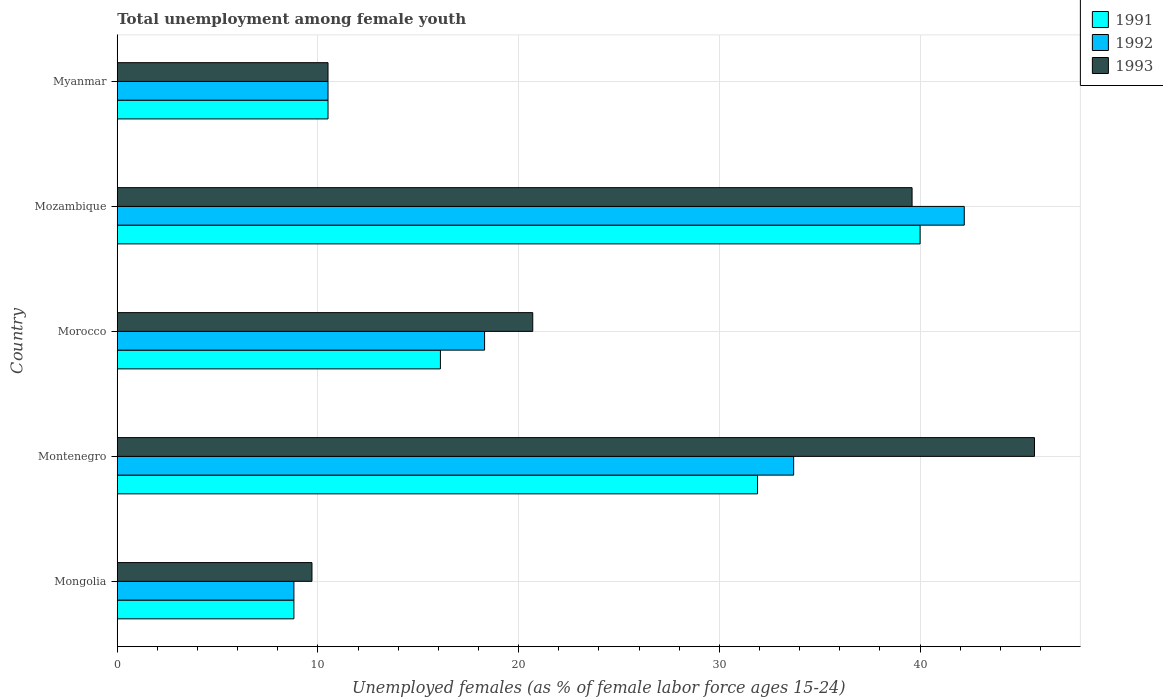Are the number of bars on each tick of the Y-axis equal?
Offer a very short reply. Yes. How many bars are there on the 5th tick from the top?
Provide a succinct answer. 3. How many bars are there on the 4th tick from the bottom?
Your response must be concise. 3. What is the label of the 2nd group of bars from the top?
Provide a succinct answer. Mozambique. What is the percentage of unemployed females in in 1993 in Morocco?
Provide a succinct answer. 20.7. Across all countries, what is the maximum percentage of unemployed females in in 1991?
Your answer should be very brief. 40. Across all countries, what is the minimum percentage of unemployed females in in 1993?
Your answer should be very brief. 9.7. In which country was the percentage of unemployed females in in 1991 maximum?
Give a very brief answer. Mozambique. In which country was the percentage of unemployed females in in 1993 minimum?
Provide a succinct answer. Mongolia. What is the total percentage of unemployed females in in 1992 in the graph?
Give a very brief answer. 113.5. What is the difference between the percentage of unemployed females in in 1993 in Morocco and that in Mozambique?
Make the answer very short. -18.9. What is the difference between the percentage of unemployed females in in 1992 in Mongolia and the percentage of unemployed females in in 1991 in Mozambique?
Keep it short and to the point. -31.2. What is the average percentage of unemployed females in in 1993 per country?
Make the answer very short. 25.24. What is the ratio of the percentage of unemployed females in in 1991 in Mozambique to that in Myanmar?
Keep it short and to the point. 3.81. Is the percentage of unemployed females in in 1993 in Mozambique less than that in Myanmar?
Make the answer very short. No. Is the difference between the percentage of unemployed females in in 1993 in Mongolia and Montenegro greater than the difference between the percentage of unemployed females in in 1992 in Mongolia and Montenegro?
Your answer should be very brief. No. What is the difference between the highest and the second highest percentage of unemployed females in in 1992?
Your answer should be very brief. 8.5. What is the difference between the highest and the lowest percentage of unemployed females in in 1991?
Offer a terse response. 31.2. What does the 3rd bar from the bottom in Mongolia represents?
Your answer should be very brief. 1993. Are all the bars in the graph horizontal?
Your answer should be very brief. Yes. How many countries are there in the graph?
Give a very brief answer. 5. What is the difference between two consecutive major ticks on the X-axis?
Your answer should be very brief. 10. Are the values on the major ticks of X-axis written in scientific E-notation?
Provide a succinct answer. No. Where does the legend appear in the graph?
Your answer should be very brief. Top right. How many legend labels are there?
Keep it short and to the point. 3. How are the legend labels stacked?
Offer a terse response. Vertical. What is the title of the graph?
Your answer should be compact. Total unemployment among female youth. What is the label or title of the X-axis?
Ensure brevity in your answer.  Unemployed females (as % of female labor force ages 15-24). What is the label or title of the Y-axis?
Offer a very short reply. Country. What is the Unemployed females (as % of female labor force ages 15-24) of 1991 in Mongolia?
Your answer should be very brief. 8.8. What is the Unemployed females (as % of female labor force ages 15-24) in 1992 in Mongolia?
Your answer should be compact. 8.8. What is the Unemployed females (as % of female labor force ages 15-24) in 1993 in Mongolia?
Offer a terse response. 9.7. What is the Unemployed females (as % of female labor force ages 15-24) of 1991 in Montenegro?
Your response must be concise. 31.9. What is the Unemployed females (as % of female labor force ages 15-24) of 1992 in Montenegro?
Your answer should be compact. 33.7. What is the Unemployed females (as % of female labor force ages 15-24) of 1993 in Montenegro?
Keep it short and to the point. 45.7. What is the Unemployed females (as % of female labor force ages 15-24) in 1991 in Morocco?
Ensure brevity in your answer.  16.1. What is the Unemployed females (as % of female labor force ages 15-24) of 1992 in Morocco?
Ensure brevity in your answer.  18.3. What is the Unemployed females (as % of female labor force ages 15-24) in 1993 in Morocco?
Your response must be concise. 20.7. What is the Unemployed females (as % of female labor force ages 15-24) of 1992 in Mozambique?
Provide a short and direct response. 42.2. What is the Unemployed females (as % of female labor force ages 15-24) in 1993 in Mozambique?
Your response must be concise. 39.6. What is the Unemployed females (as % of female labor force ages 15-24) in 1993 in Myanmar?
Your answer should be compact. 10.5. Across all countries, what is the maximum Unemployed females (as % of female labor force ages 15-24) in 1992?
Give a very brief answer. 42.2. Across all countries, what is the maximum Unemployed females (as % of female labor force ages 15-24) of 1993?
Your response must be concise. 45.7. Across all countries, what is the minimum Unemployed females (as % of female labor force ages 15-24) of 1991?
Keep it short and to the point. 8.8. Across all countries, what is the minimum Unemployed females (as % of female labor force ages 15-24) of 1992?
Offer a very short reply. 8.8. Across all countries, what is the minimum Unemployed females (as % of female labor force ages 15-24) of 1993?
Your answer should be compact. 9.7. What is the total Unemployed females (as % of female labor force ages 15-24) of 1991 in the graph?
Your answer should be compact. 107.3. What is the total Unemployed females (as % of female labor force ages 15-24) of 1992 in the graph?
Keep it short and to the point. 113.5. What is the total Unemployed females (as % of female labor force ages 15-24) in 1993 in the graph?
Offer a very short reply. 126.2. What is the difference between the Unemployed females (as % of female labor force ages 15-24) in 1991 in Mongolia and that in Montenegro?
Ensure brevity in your answer.  -23.1. What is the difference between the Unemployed females (as % of female labor force ages 15-24) of 1992 in Mongolia and that in Montenegro?
Your answer should be very brief. -24.9. What is the difference between the Unemployed females (as % of female labor force ages 15-24) in 1993 in Mongolia and that in Montenegro?
Offer a very short reply. -36. What is the difference between the Unemployed females (as % of female labor force ages 15-24) of 1991 in Mongolia and that in Mozambique?
Your response must be concise. -31.2. What is the difference between the Unemployed females (as % of female labor force ages 15-24) in 1992 in Mongolia and that in Mozambique?
Your answer should be compact. -33.4. What is the difference between the Unemployed females (as % of female labor force ages 15-24) of 1993 in Mongolia and that in Mozambique?
Provide a succinct answer. -29.9. What is the difference between the Unemployed females (as % of female labor force ages 15-24) of 1991 in Mongolia and that in Myanmar?
Offer a very short reply. -1.7. What is the difference between the Unemployed females (as % of female labor force ages 15-24) of 1993 in Montenegro and that in Morocco?
Give a very brief answer. 25. What is the difference between the Unemployed females (as % of female labor force ages 15-24) of 1992 in Montenegro and that in Mozambique?
Give a very brief answer. -8.5. What is the difference between the Unemployed females (as % of female labor force ages 15-24) of 1991 in Montenegro and that in Myanmar?
Provide a short and direct response. 21.4. What is the difference between the Unemployed females (as % of female labor force ages 15-24) of 1992 in Montenegro and that in Myanmar?
Provide a succinct answer. 23.2. What is the difference between the Unemployed females (as % of female labor force ages 15-24) of 1993 in Montenegro and that in Myanmar?
Keep it short and to the point. 35.2. What is the difference between the Unemployed females (as % of female labor force ages 15-24) in 1991 in Morocco and that in Mozambique?
Your response must be concise. -23.9. What is the difference between the Unemployed females (as % of female labor force ages 15-24) in 1992 in Morocco and that in Mozambique?
Offer a terse response. -23.9. What is the difference between the Unemployed females (as % of female labor force ages 15-24) in 1993 in Morocco and that in Mozambique?
Offer a very short reply. -18.9. What is the difference between the Unemployed females (as % of female labor force ages 15-24) of 1992 in Morocco and that in Myanmar?
Provide a short and direct response. 7.8. What is the difference between the Unemployed females (as % of female labor force ages 15-24) in 1991 in Mozambique and that in Myanmar?
Your answer should be very brief. 29.5. What is the difference between the Unemployed females (as % of female labor force ages 15-24) of 1992 in Mozambique and that in Myanmar?
Provide a succinct answer. 31.7. What is the difference between the Unemployed females (as % of female labor force ages 15-24) of 1993 in Mozambique and that in Myanmar?
Make the answer very short. 29.1. What is the difference between the Unemployed females (as % of female labor force ages 15-24) in 1991 in Mongolia and the Unemployed females (as % of female labor force ages 15-24) in 1992 in Montenegro?
Your answer should be compact. -24.9. What is the difference between the Unemployed females (as % of female labor force ages 15-24) of 1991 in Mongolia and the Unemployed females (as % of female labor force ages 15-24) of 1993 in Montenegro?
Provide a succinct answer. -36.9. What is the difference between the Unemployed females (as % of female labor force ages 15-24) of 1992 in Mongolia and the Unemployed females (as % of female labor force ages 15-24) of 1993 in Montenegro?
Your response must be concise. -36.9. What is the difference between the Unemployed females (as % of female labor force ages 15-24) of 1991 in Mongolia and the Unemployed females (as % of female labor force ages 15-24) of 1992 in Morocco?
Provide a succinct answer. -9.5. What is the difference between the Unemployed females (as % of female labor force ages 15-24) of 1991 in Mongolia and the Unemployed females (as % of female labor force ages 15-24) of 1992 in Mozambique?
Offer a terse response. -33.4. What is the difference between the Unemployed females (as % of female labor force ages 15-24) of 1991 in Mongolia and the Unemployed females (as % of female labor force ages 15-24) of 1993 in Mozambique?
Your answer should be compact. -30.8. What is the difference between the Unemployed females (as % of female labor force ages 15-24) of 1992 in Mongolia and the Unemployed females (as % of female labor force ages 15-24) of 1993 in Mozambique?
Provide a short and direct response. -30.8. What is the difference between the Unemployed females (as % of female labor force ages 15-24) of 1991 in Mongolia and the Unemployed females (as % of female labor force ages 15-24) of 1992 in Myanmar?
Keep it short and to the point. -1.7. What is the difference between the Unemployed females (as % of female labor force ages 15-24) of 1991 in Mongolia and the Unemployed females (as % of female labor force ages 15-24) of 1993 in Myanmar?
Your answer should be compact. -1.7. What is the difference between the Unemployed females (as % of female labor force ages 15-24) of 1991 in Montenegro and the Unemployed females (as % of female labor force ages 15-24) of 1993 in Morocco?
Your answer should be compact. 11.2. What is the difference between the Unemployed females (as % of female labor force ages 15-24) in 1992 in Montenegro and the Unemployed females (as % of female labor force ages 15-24) in 1993 in Morocco?
Offer a terse response. 13. What is the difference between the Unemployed females (as % of female labor force ages 15-24) in 1991 in Montenegro and the Unemployed females (as % of female labor force ages 15-24) in 1993 in Mozambique?
Keep it short and to the point. -7.7. What is the difference between the Unemployed females (as % of female labor force ages 15-24) in 1991 in Montenegro and the Unemployed females (as % of female labor force ages 15-24) in 1992 in Myanmar?
Provide a short and direct response. 21.4. What is the difference between the Unemployed females (as % of female labor force ages 15-24) in 1991 in Montenegro and the Unemployed females (as % of female labor force ages 15-24) in 1993 in Myanmar?
Provide a succinct answer. 21.4. What is the difference between the Unemployed females (as % of female labor force ages 15-24) of 1992 in Montenegro and the Unemployed females (as % of female labor force ages 15-24) of 1993 in Myanmar?
Ensure brevity in your answer.  23.2. What is the difference between the Unemployed females (as % of female labor force ages 15-24) of 1991 in Morocco and the Unemployed females (as % of female labor force ages 15-24) of 1992 in Mozambique?
Give a very brief answer. -26.1. What is the difference between the Unemployed females (as % of female labor force ages 15-24) of 1991 in Morocco and the Unemployed females (as % of female labor force ages 15-24) of 1993 in Mozambique?
Offer a terse response. -23.5. What is the difference between the Unemployed females (as % of female labor force ages 15-24) in 1992 in Morocco and the Unemployed females (as % of female labor force ages 15-24) in 1993 in Mozambique?
Provide a short and direct response. -21.3. What is the difference between the Unemployed females (as % of female labor force ages 15-24) in 1992 in Morocco and the Unemployed females (as % of female labor force ages 15-24) in 1993 in Myanmar?
Provide a succinct answer. 7.8. What is the difference between the Unemployed females (as % of female labor force ages 15-24) in 1991 in Mozambique and the Unemployed females (as % of female labor force ages 15-24) in 1992 in Myanmar?
Your response must be concise. 29.5. What is the difference between the Unemployed females (as % of female labor force ages 15-24) in 1991 in Mozambique and the Unemployed females (as % of female labor force ages 15-24) in 1993 in Myanmar?
Give a very brief answer. 29.5. What is the difference between the Unemployed females (as % of female labor force ages 15-24) of 1992 in Mozambique and the Unemployed females (as % of female labor force ages 15-24) of 1993 in Myanmar?
Your answer should be very brief. 31.7. What is the average Unemployed females (as % of female labor force ages 15-24) of 1991 per country?
Your answer should be very brief. 21.46. What is the average Unemployed females (as % of female labor force ages 15-24) of 1992 per country?
Your answer should be very brief. 22.7. What is the average Unemployed females (as % of female labor force ages 15-24) in 1993 per country?
Make the answer very short. 25.24. What is the difference between the Unemployed females (as % of female labor force ages 15-24) in 1991 and Unemployed females (as % of female labor force ages 15-24) in 1993 in Montenegro?
Keep it short and to the point. -13.8. What is the difference between the Unemployed females (as % of female labor force ages 15-24) in 1992 and Unemployed females (as % of female labor force ages 15-24) in 1993 in Montenegro?
Give a very brief answer. -12. What is the difference between the Unemployed females (as % of female labor force ages 15-24) of 1991 and Unemployed females (as % of female labor force ages 15-24) of 1992 in Morocco?
Keep it short and to the point. -2.2. What is the difference between the Unemployed females (as % of female labor force ages 15-24) in 1991 and Unemployed females (as % of female labor force ages 15-24) in 1992 in Mozambique?
Make the answer very short. -2.2. What is the difference between the Unemployed females (as % of female labor force ages 15-24) of 1991 and Unemployed females (as % of female labor force ages 15-24) of 1993 in Mozambique?
Your response must be concise. 0.4. What is the difference between the Unemployed females (as % of female labor force ages 15-24) in 1992 and Unemployed females (as % of female labor force ages 15-24) in 1993 in Mozambique?
Your answer should be very brief. 2.6. What is the difference between the Unemployed females (as % of female labor force ages 15-24) in 1991 and Unemployed females (as % of female labor force ages 15-24) in 1992 in Myanmar?
Offer a terse response. 0. What is the difference between the Unemployed females (as % of female labor force ages 15-24) of 1992 and Unemployed females (as % of female labor force ages 15-24) of 1993 in Myanmar?
Give a very brief answer. 0. What is the ratio of the Unemployed females (as % of female labor force ages 15-24) in 1991 in Mongolia to that in Montenegro?
Make the answer very short. 0.28. What is the ratio of the Unemployed females (as % of female labor force ages 15-24) in 1992 in Mongolia to that in Montenegro?
Make the answer very short. 0.26. What is the ratio of the Unemployed females (as % of female labor force ages 15-24) in 1993 in Mongolia to that in Montenegro?
Your response must be concise. 0.21. What is the ratio of the Unemployed females (as % of female labor force ages 15-24) in 1991 in Mongolia to that in Morocco?
Ensure brevity in your answer.  0.55. What is the ratio of the Unemployed females (as % of female labor force ages 15-24) of 1992 in Mongolia to that in Morocco?
Give a very brief answer. 0.48. What is the ratio of the Unemployed females (as % of female labor force ages 15-24) of 1993 in Mongolia to that in Morocco?
Offer a very short reply. 0.47. What is the ratio of the Unemployed females (as % of female labor force ages 15-24) in 1991 in Mongolia to that in Mozambique?
Ensure brevity in your answer.  0.22. What is the ratio of the Unemployed females (as % of female labor force ages 15-24) in 1992 in Mongolia to that in Mozambique?
Give a very brief answer. 0.21. What is the ratio of the Unemployed females (as % of female labor force ages 15-24) of 1993 in Mongolia to that in Mozambique?
Your answer should be compact. 0.24. What is the ratio of the Unemployed females (as % of female labor force ages 15-24) of 1991 in Mongolia to that in Myanmar?
Provide a short and direct response. 0.84. What is the ratio of the Unemployed females (as % of female labor force ages 15-24) in 1992 in Mongolia to that in Myanmar?
Provide a succinct answer. 0.84. What is the ratio of the Unemployed females (as % of female labor force ages 15-24) in 1993 in Mongolia to that in Myanmar?
Provide a succinct answer. 0.92. What is the ratio of the Unemployed females (as % of female labor force ages 15-24) in 1991 in Montenegro to that in Morocco?
Ensure brevity in your answer.  1.98. What is the ratio of the Unemployed females (as % of female labor force ages 15-24) in 1992 in Montenegro to that in Morocco?
Give a very brief answer. 1.84. What is the ratio of the Unemployed females (as % of female labor force ages 15-24) in 1993 in Montenegro to that in Morocco?
Provide a short and direct response. 2.21. What is the ratio of the Unemployed females (as % of female labor force ages 15-24) in 1991 in Montenegro to that in Mozambique?
Ensure brevity in your answer.  0.8. What is the ratio of the Unemployed females (as % of female labor force ages 15-24) of 1992 in Montenegro to that in Mozambique?
Your answer should be compact. 0.8. What is the ratio of the Unemployed females (as % of female labor force ages 15-24) of 1993 in Montenegro to that in Mozambique?
Your answer should be compact. 1.15. What is the ratio of the Unemployed females (as % of female labor force ages 15-24) in 1991 in Montenegro to that in Myanmar?
Give a very brief answer. 3.04. What is the ratio of the Unemployed females (as % of female labor force ages 15-24) in 1992 in Montenegro to that in Myanmar?
Your answer should be very brief. 3.21. What is the ratio of the Unemployed females (as % of female labor force ages 15-24) of 1993 in Montenegro to that in Myanmar?
Your answer should be compact. 4.35. What is the ratio of the Unemployed females (as % of female labor force ages 15-24) of 1991 in Morocco to that in Mozambique?
Offer a very short reply. 0.4. What is the ratio of the Unemployed females (as % of female labor force ages 15-24) of 1992 in Morocco to that in Mozambique?
Your answer should be compact. 0.43. What is the ratio of the Unemployed females (as % of female labor force ages 15-24) in 1993 in Morocco to that in Mozambique?
Provide a succinct answer. 0.52. What is the ratio of the Unemployed females (as % of female labor force ages 15-24) of 1991 in Morocco to that in Myanmar?
Keep it short and to the point. 1.53. What is the ratio of the Unemployed females (as % of female labor force ages 15-24) in 1992 in Morocco to that in Myanmar?
Your response must be concise. 1.74. What is the ratio of the Unemployed females (as % of female labor force ages 15-24) of 1993 in Morocco to that in Myanmar?
Offer a terse response. 1.97. What is the ratio of the Unemployed females (as % of female labor force ages 15-24) in 1991 in Mozambique to that in Myanmar?
Offer a terse response. 3.81. What is the ratio of the Unemployed females (as % of female labor force ages 15-24) in 1992 in Mozambique to that in Myanmar?
Your response must be concise. 4.02. What is the ratio of the Unemployed females (as % of female labor force ages 15-24) in 1993 in Mozambique to that in Myanmar?
Your answer should be very brief. 3.77. What is the difference between the highest and the second highest Unemployed females (as % of female labor force ages 15-24) in 1992?
Make the answer very short. 8.5. What is the difference between the highest and the second highest Unemployed females (as % of female labor force ages 15-24) of 1993?
Make the answer very short. 6.1. What is the difference between the highest and the lowest Unemployed females (as % of female labor force ages 15-24) in 1991?
Give a very brief answer. 31.2. What is the difference between the highest and the lowest Unemployed females (as % of female labor force ages 15-24) of 1992?
Your answer should be compact. 33.4. What is the difference between the highest and the lowest Unemployed females (as % of female labor force ages 15-24) of 1993?
Ensure brevity in your answer.  36. 